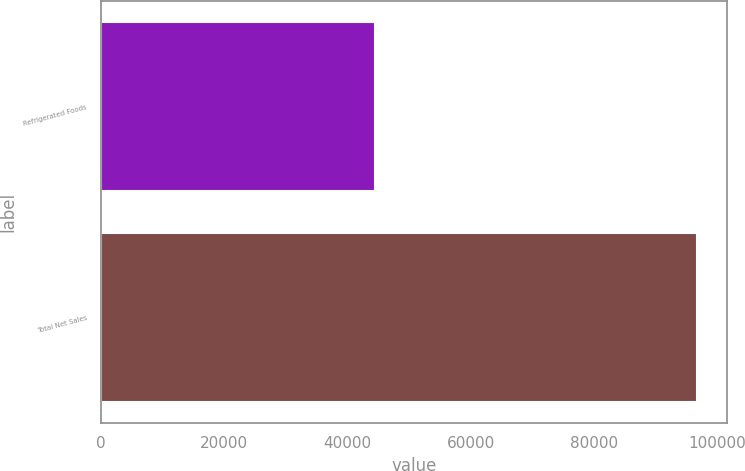<chart> <loc_0><loc_0><loc_500><loc_500><bar_chart><fcel>Refrigerated Foods<fcel>Total Net Sales<nl><fcel>44450<fcel>96748<nl></chart> 